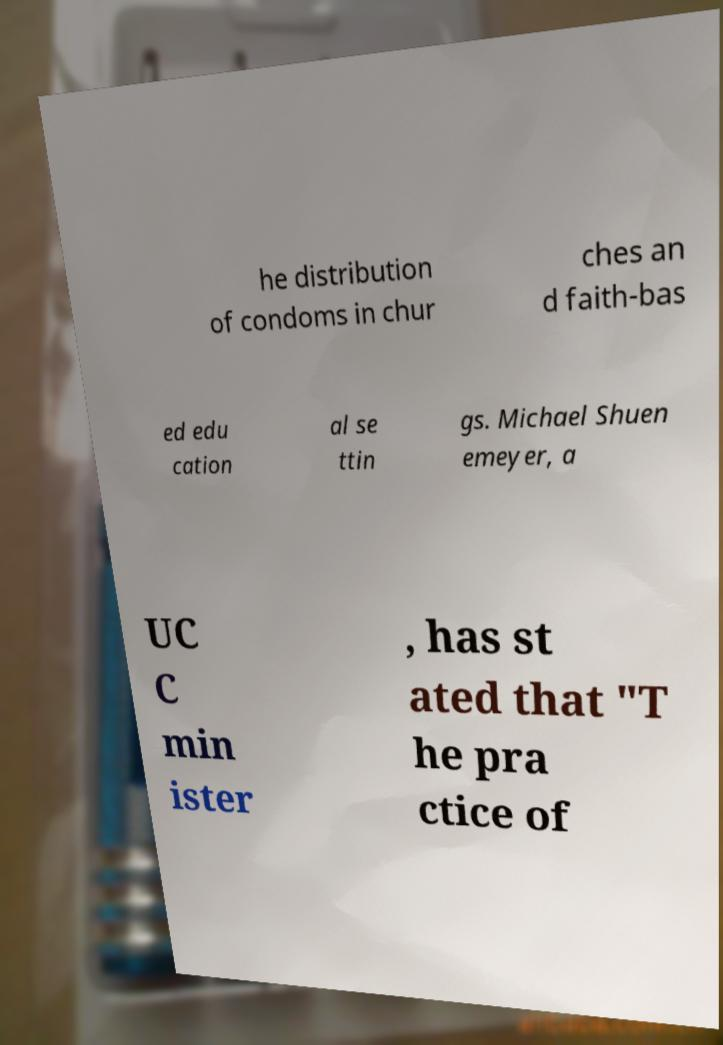What messages or text are displayed in this image? I need them in a readable, typed format. he distribution of condoms in chur ches an d faith-bas ed edu cation al se ttin gs. Michael Shuen emeyer, a UC C min ister , has st ated that "T he pra ctice of 